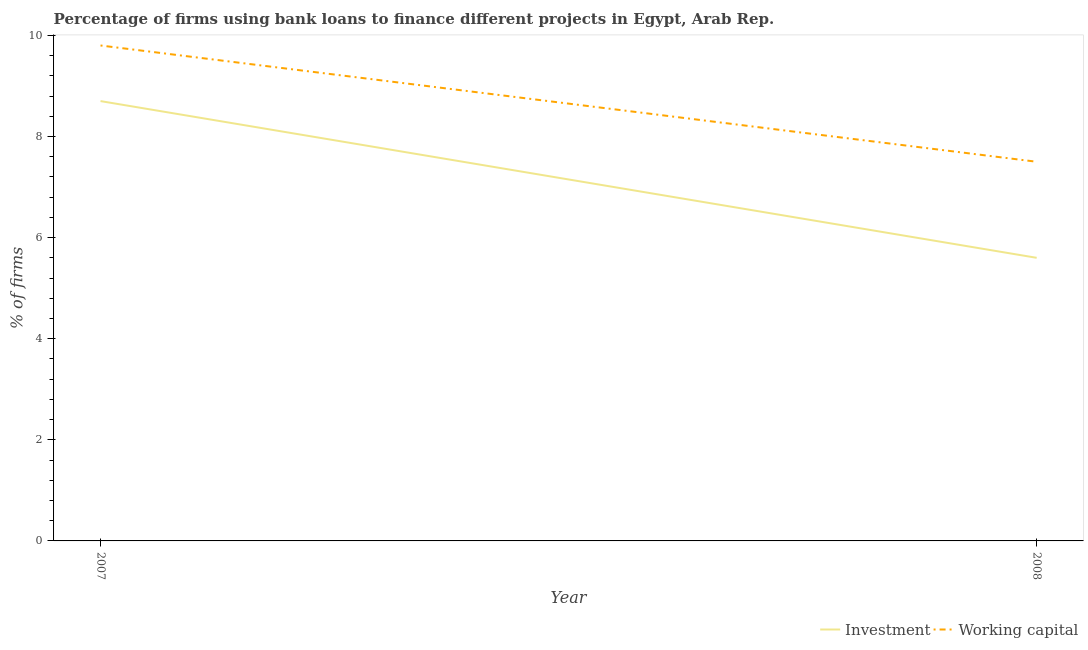How many different coloured lines are there?
Make the answer very short. 2. Is the number of lines equal to the number of legend labels?
Provide a succinct answer. Yes. What is the percentage of firms using banks to finance investment in 2008?
Provide a short and direct response. 5.6. Across all years, what is the maximum percentage of firms using banks to finance investment?
Your answer should be compact. 8.7. What is the total percentage of firms using banks to finance investment in the graph?
Offer a terse response. 14.3. What is the difference between the percentage of firms using banks to finance investment in 2007 and that in 2008?
Provide a short and direct response. 3.1. What is the difference between the percentage of firms using banks to finance working capital in 2008 and the percentage of firms using banks to finance investment in 2007?
Provide a short and direct response. -1.2. What is the average percentage of firms using banks to finance working capital per year?
Offer a very short reply. 8.65. In the year 2008, what is the difference between the percentage of firms using banks to finance investment and percentage of firms using banks to finance working capital?
Keep it short and to the point. -1.9. In how many years, is the percentage of firms using banks to finance investment greater than 9.2 %?
Keep it short and to the point. 0. What is the ratio of the percentage of firms using banks to finance working capital in 2007 to that in 2008?
Offer a very short reply. 1.31. In how many years, is the percentage of firms using banks to finance investment greater than the average percentage of firms using banks to finance investment taken over all years?
Offer a very short reply. 1. Does the percentage of firms using banks to finance working capital monotonically increase over the years?
Provide a succinct answer. No. Is the percentage of firms using banks to finance investment strictly greater than the percentage of firms using banks to finance working capital over the years?
Your answer should be compact. No. Is the percentage of firms using banks to finance investment strictly less than the percentage of firms using banks to finance working capital over the years?
Your answer should be very brief. Yes. Are the values on the major ticks of Y-axis written in scientific E-notation?
Offer a terse response. No. Does the graph contain any zero values?
Offer a terse response. No. Does the graph contain grids?
Your answer should be very brief. No. How many legend labels are there?
Provide a succinct answer. 2. How are the legend labels stacked?
Offer a terse response. Horizontal. What is the title of the graph?
Your answer should be compact. Percentage of firms using bank loans to finance different projects in Egypt, Arab Rep. What is the label or title of the X-axis?
Offer a very short reply. Year. What is the label or title of the Y-axis?
Provide a succinct answer. % of firms. What is the % of firms in Working capital in 2007?
Provide a short and direct response. 9.8. Across all years, what is the maximum % of firms of Investment?
Keep it short and to the point. 8.7. What is the total % of firms in Investment in the graph?
Provide a short and direct response. 14.3. What is the total % of firms in Working capital in the graph?
Your response must be concise. 17.3. What is the difference between the % of firms of Investment in 2007 and that in 2008?
Your response must be concise. 3.1. What is the difference between the % of firms in Investment in 2007 and the % of firms in Working capital in 2008?
Your answer should be compact. 1.2. What is the average % of firms of Investment per year?
Give a very brief answer. 7.15. What is the average % of firms of Working capital per year?
Ensure brevity in your answer.  8.65. In the year 2007, what is the difference between the % of firms of Investment and % of firms of Working capital?
Give a very brief answer. -1.1. In the year 2008, what is the difference between the % of firms in Investment and % of firms in Working capital?
Offer a very short reply. -1.9. What is the ratio of the % of firms in Investment in 2007 to that in 2008?
Ensure brevity in your answer.  1.55. What is the ratio of the % of firms of Working capital in 2007 to that in 2008?
Keep it short and to the point. 1.31. What is the difference between the highest and the second highest % of firms of Investment?
Your answer should be very brief. 3.1. What is the difference between the highest and the second highest % of firms in Working capital?
Your response must be concise. 2.3. What is the difference between the highest and the lowest % of firms of Investment?
Ensure brevity in your answer.  3.1. What is the difference between the highest and the lowest % of firms in Working capital?
Make the answer very short. 2.3. 